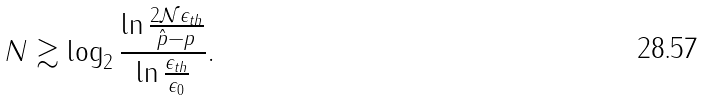Convert formula to latex. <formula><loc_0><loc_0><loc_500><loc_500>N \gtrsim \log _ { 2 } \frac { \ln \frac { 2 \mathcal { N } \epsilon _ { t h } } { \hat { p } - p } } { \ln \frac { \epsilon _ { t h } } { \epsilon _ { 0 } } } .</formula> 